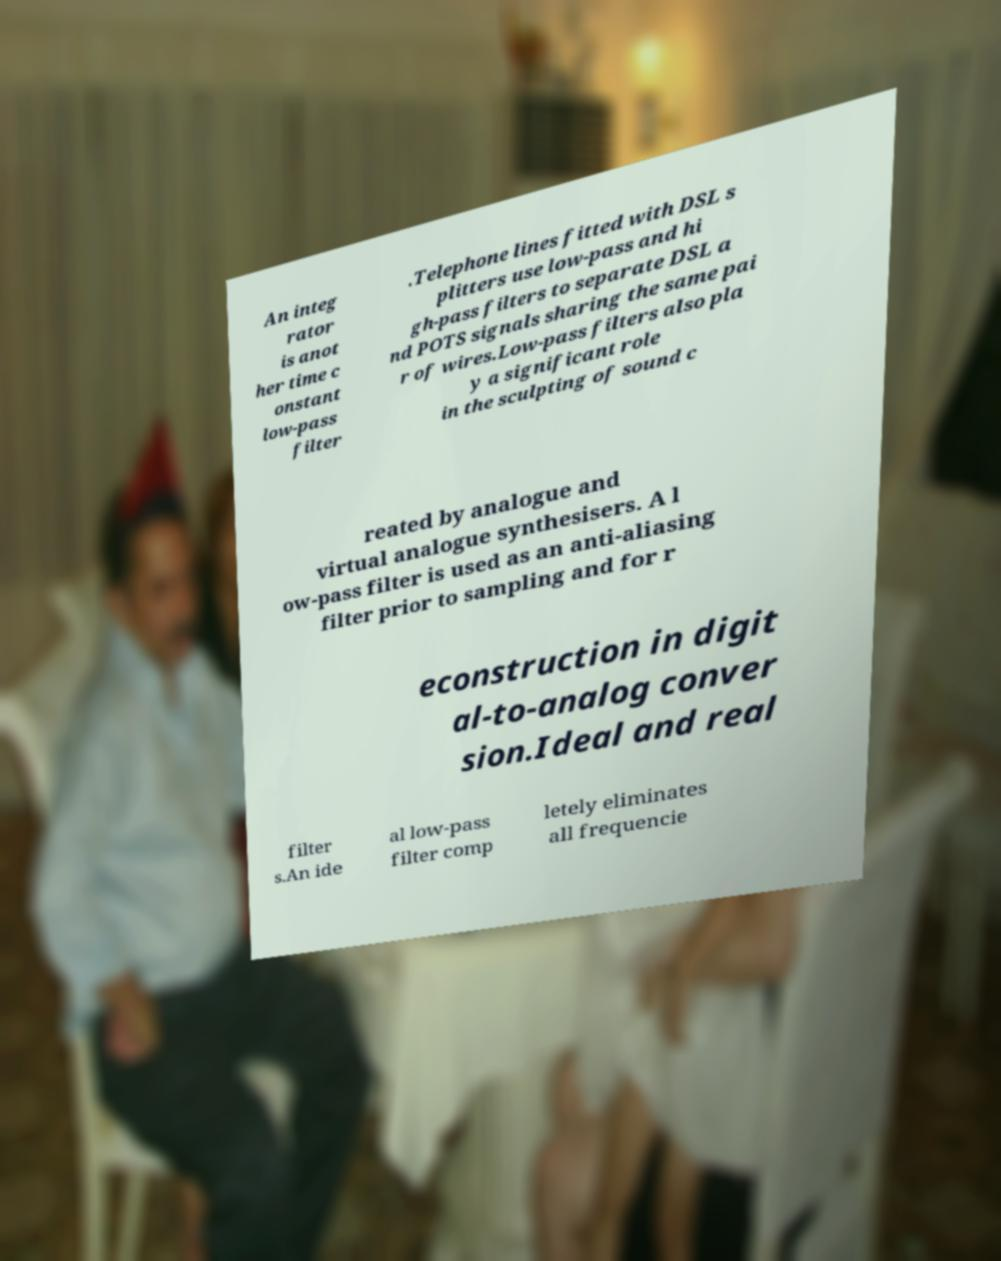Please read and relay the text visible in this image. What does it say? An integ rator is anot her time c onstant low-pass filter .Telephone lines fitted with DSL s plitters use low-pass and hi gh-pass filters to separate DSL a nd POTS signals sharing the same pai r of wires.Low-pass filters also pla y a significant role in the sculpting of sound c reated by analogue and virtual analogue synthesisers. A l ow-pass filter is used as an anti-aliasing filter prior to sampling and for r econstruction in digit al-to-analog conver sion.Ideal and real filter s.An ide al low-pass filter comp letely eliminates all frequencie 